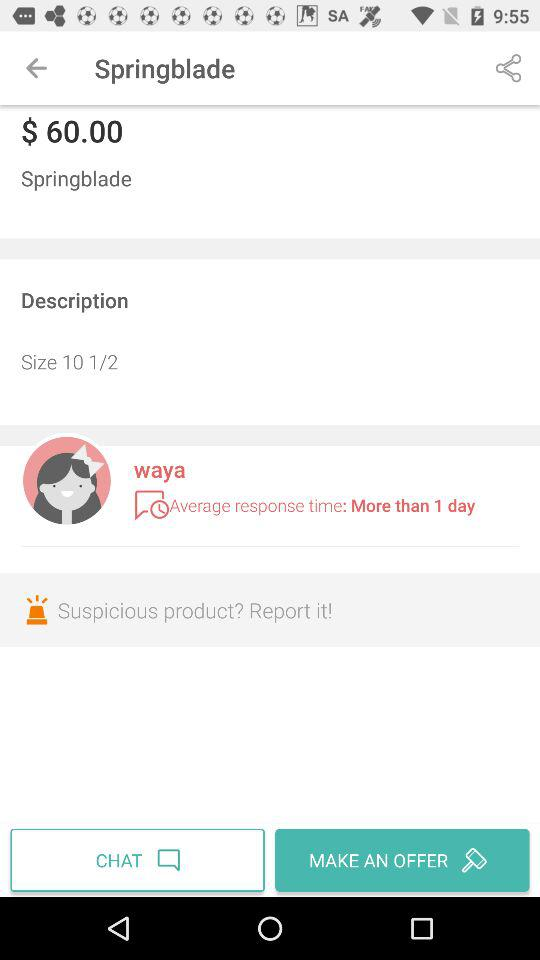How many days does it take for the seller to respond on average?
Answer the question using a single word or phrase. More than 1 day 